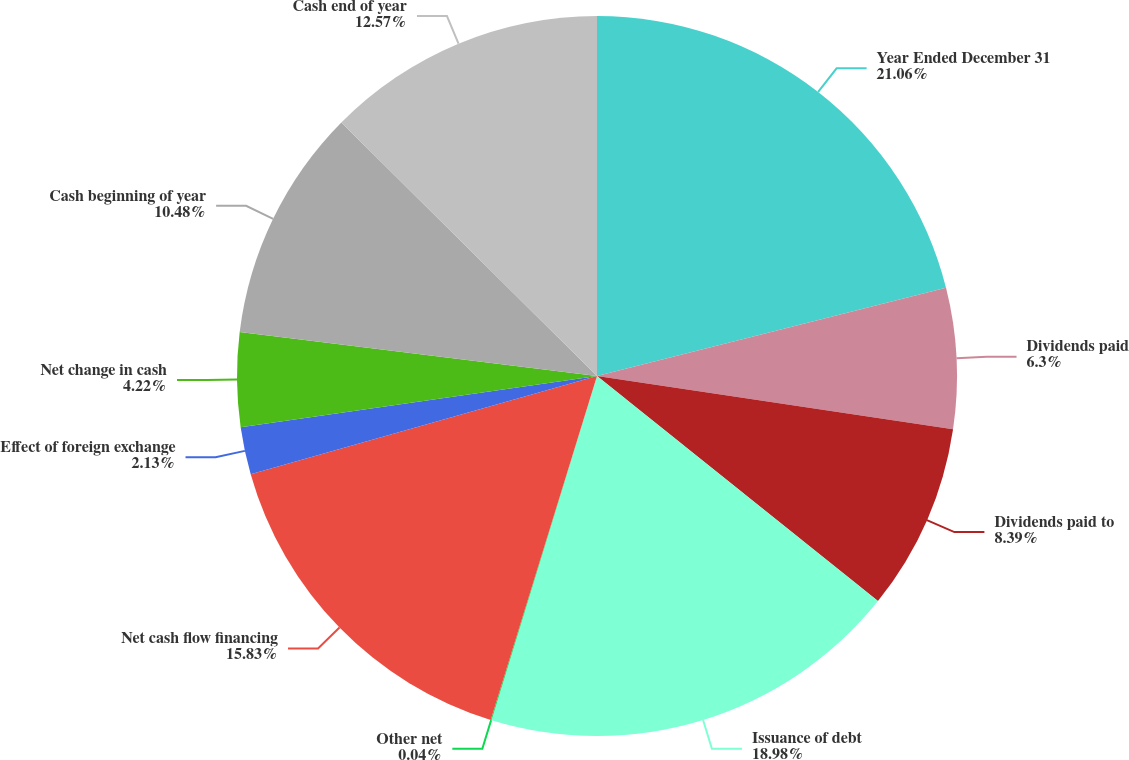Convert chart to OTSL. <chart><loc_0><loc_0><loc_500><loc_500><pie_chart><fcel>Year Ended December 31<fcel>Dividends paid<fcel>Dividends paid to<fcel>Issuance of debt<fcel>Other net<fcel>Net cash flow financing<fcel>Effect of foreign exchange<fcel>Net change in cash<fcel>Cash beginning of year<fcel>Cash end of year<nl><fcel>21.06%<fcel>6.3%<fcel>8.39%<fcel>18.98%<fcel>0.04%<fcel>15.83%<fcel>2.13%<fcel>4.22%<fcel>10.48%<fcel>12.57%<nl></chart> 